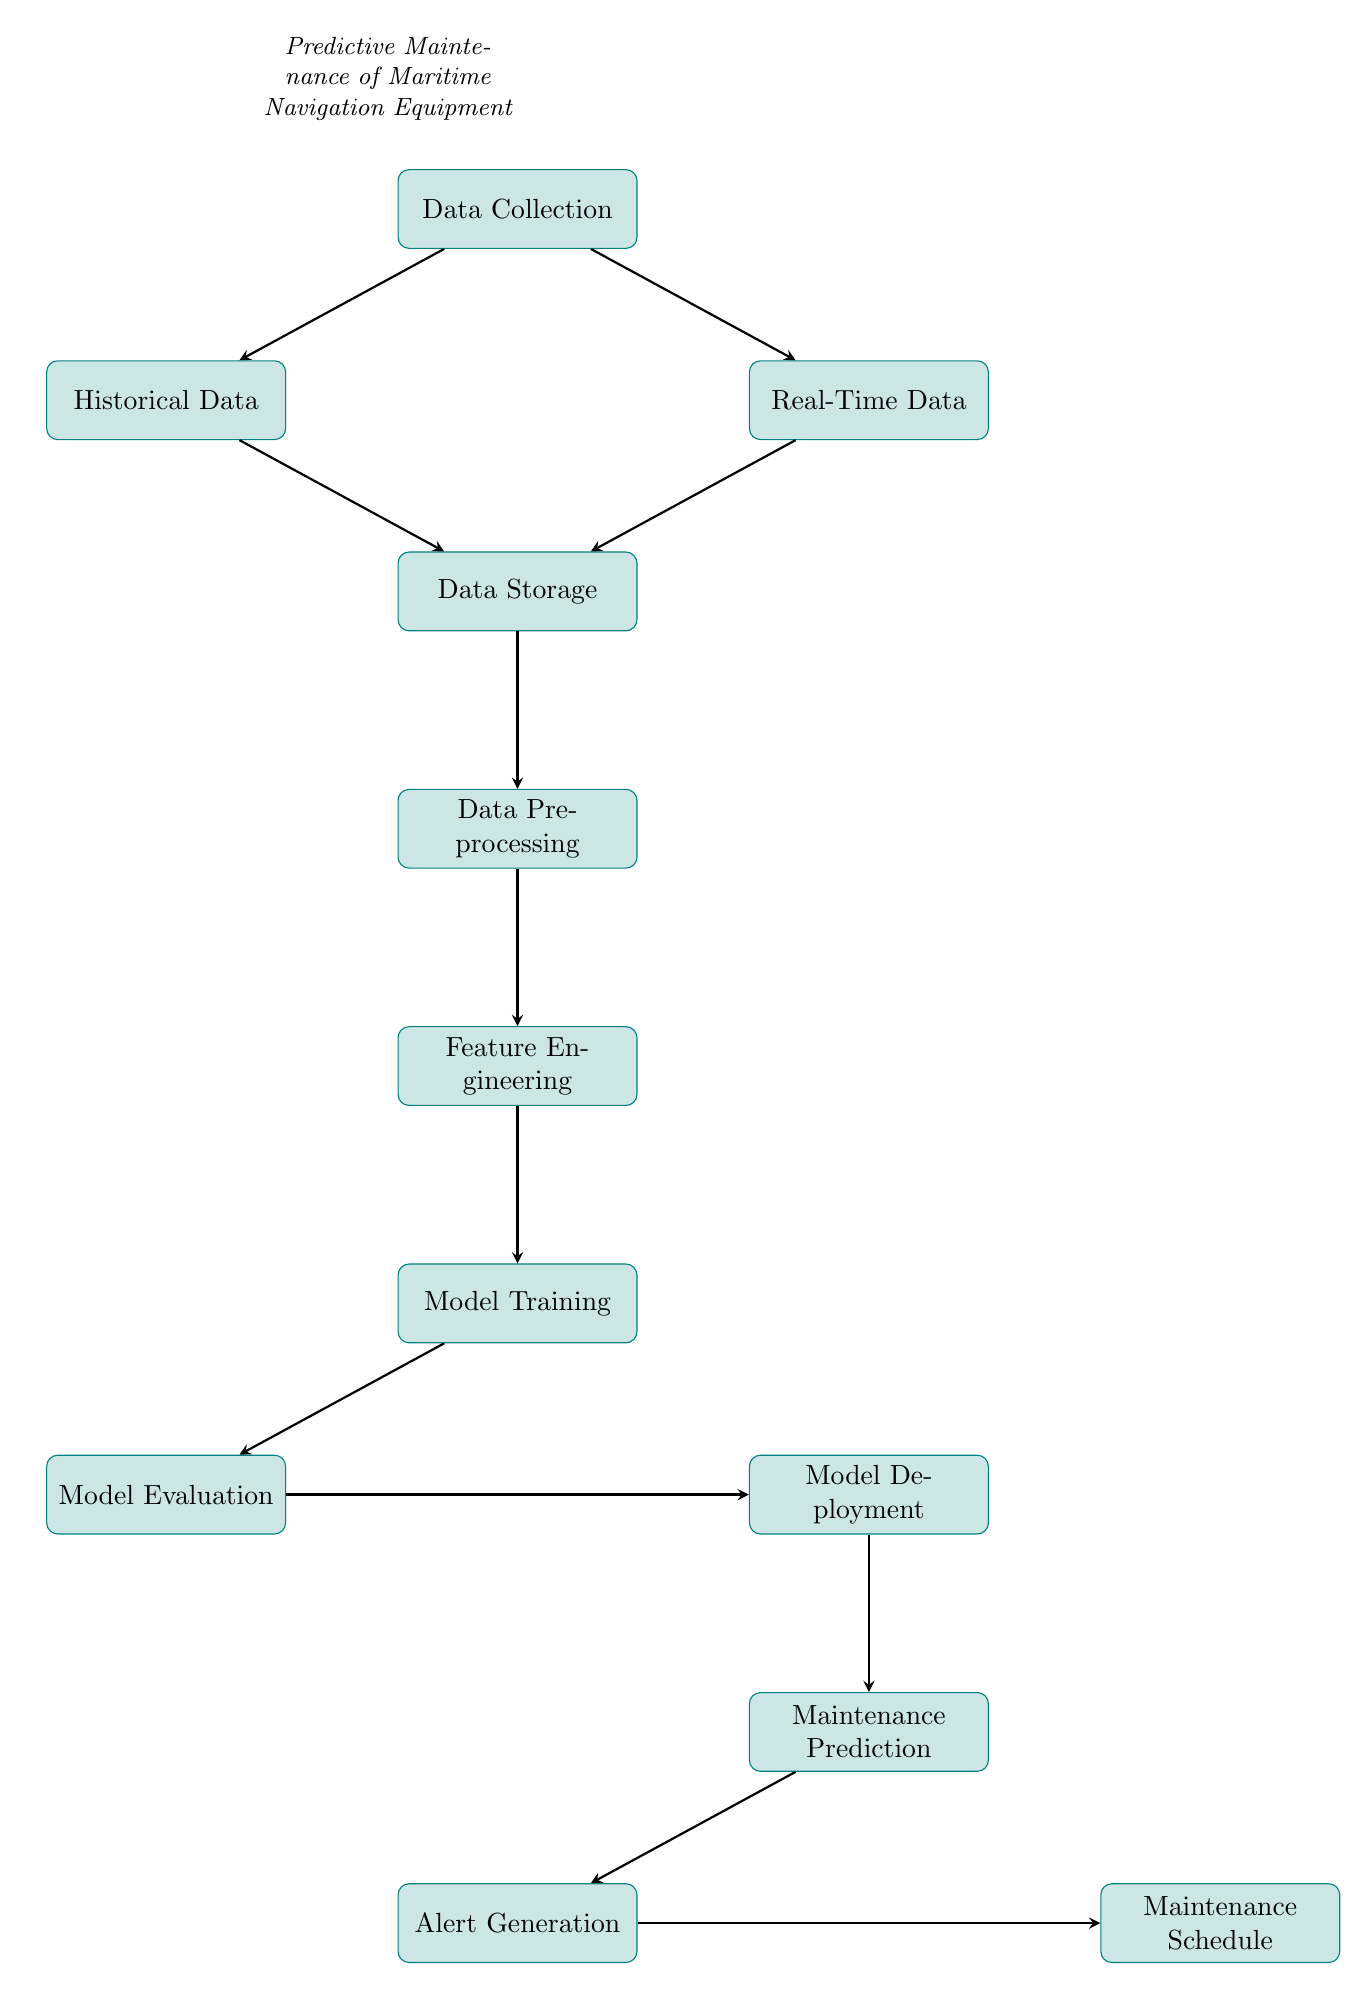What is the first step in the predictive maintenance process? The first step in the diagram is "Data Collection," which is the starting point for all subsequent processes.
Answer: Data Collection How many processes are involved in the predictive maintenance flow? Counting the rectangles in the diagram, there are a total of 11 processes involved in the flow.
Answer: 11 Which two types of data are collected initially? The diagram shows that "Historical Data" and "Real-Time Data" are the two types of data collected immediately after the "Data Collection" step.
Answer: Historical Data and Real-Time Data What process directly follows "Feature Engineering"? The process that follows "Feature Engineering" is "Model Training," indicating a sequential flow in the predictive maintenance pipeline.
Answer: Model Training What happens after "Model Deployment"? Following "Model Deployment," the diagram indicates that "Maintenance Prediction" occurs, which is the next logical step in utilizing the deployed model.
Answer: Maintenance Prediction How do historical and real-time data contribute to the predictive maintenance process? Both "Historical Data" and "Real-Time Data" feed into "Data Storage," which consolidates the data for further processing, indicating their importance in the overall process.
Answer: Data Storage What is generated as a result of "Maintenance Prediction"? The output from "Maintenance Prediction" is "Alert Generation," which follows as the next step in the process, demonstrating a predictive response based on the model's output.
Answer: Alert Generation Where does "Maintenance Schedule" fit in the overall flow? "Maintenance Schedule" is the final step in the predictive maintenance process, generated from "Alert Generation," concluding the flow of activities in the diagram.
Answer: Maintenance Schedule What type of diagram is depicted here? The diagram represents a "Machine Learning Diagram," focusing on the stages of predictive maintenance specific to maritime navigation equipment.
Answer: Machine Learning Diagram 